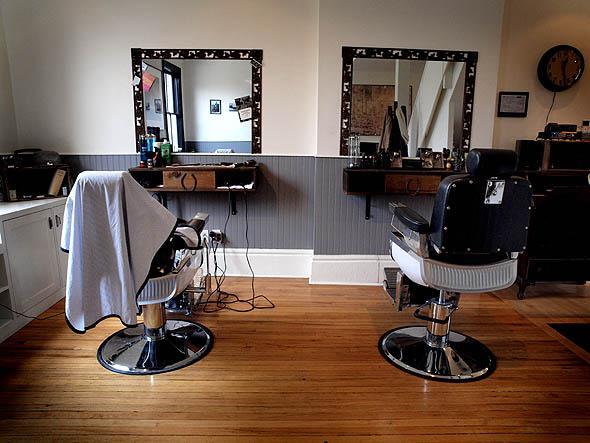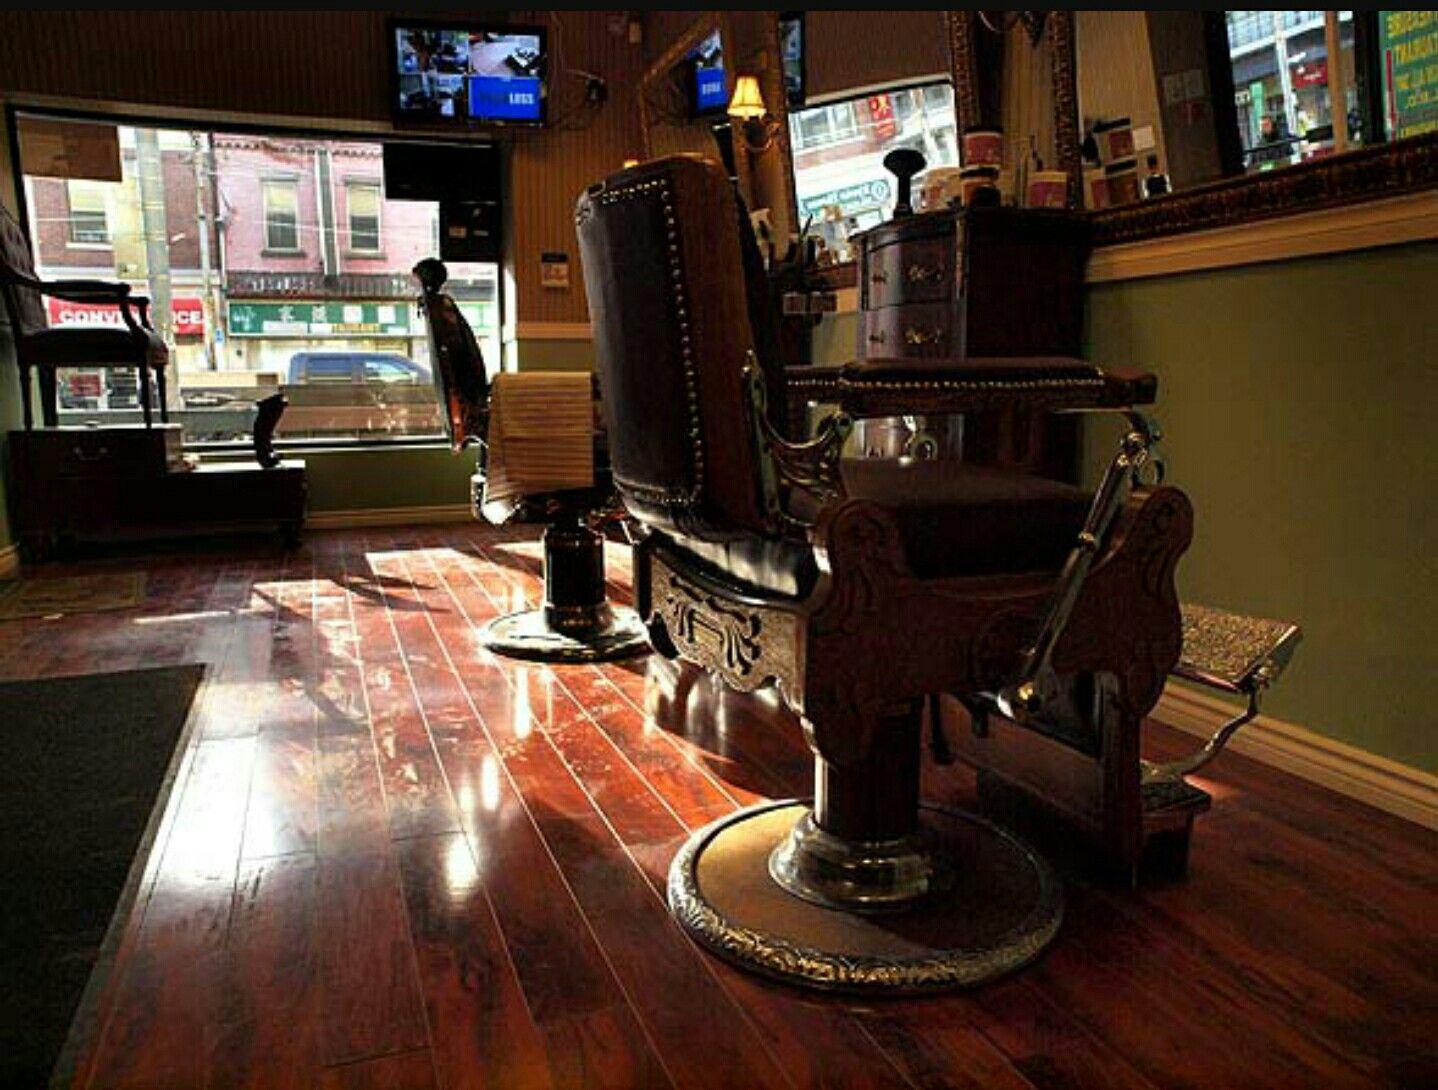The first image is the image on the left, the second image is the image on the right. Given the left and right images, does the statement "There is a total of four barber chairs." hold true? Answer yes or no. Yes. 